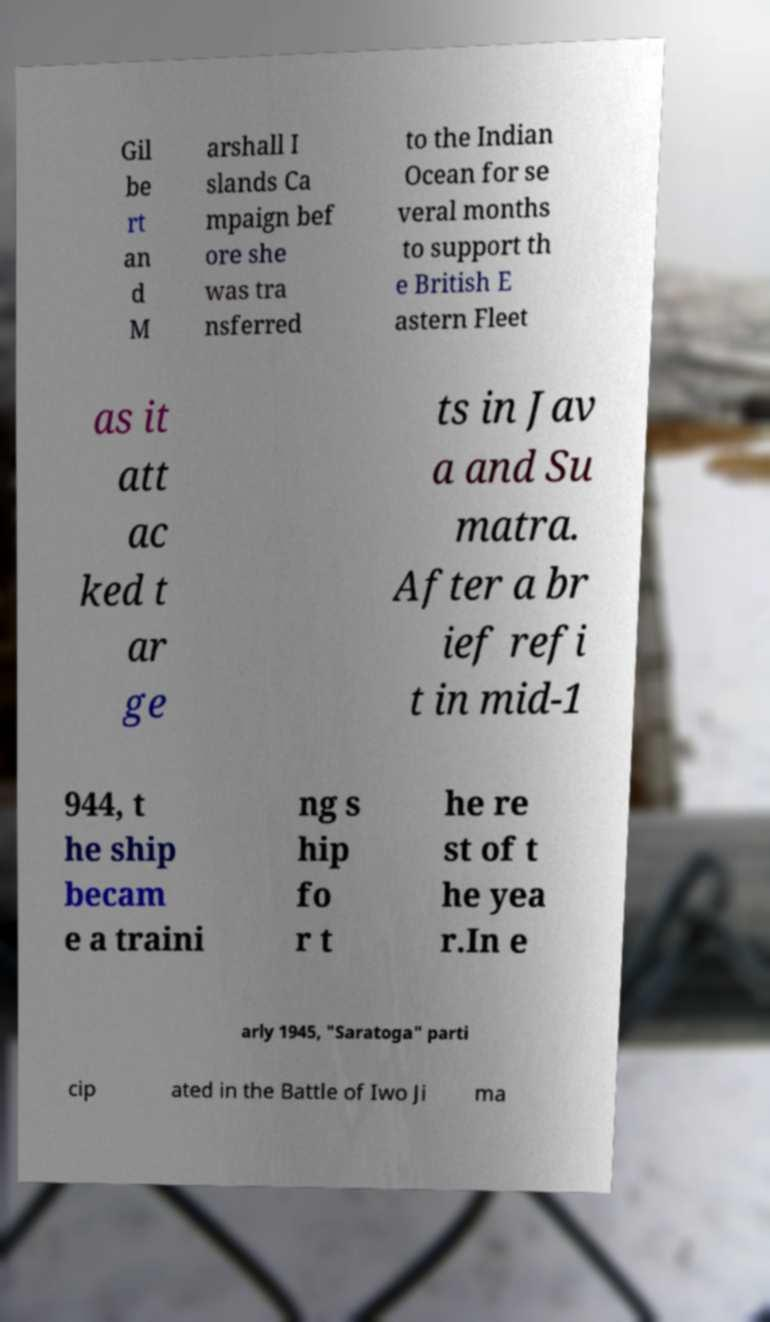Can you accurately transcribe the text from the provided image for me? Gil be rt an d M arshall I slands Ca mpaign bef ore she was tra nsferred to the Indian Ocean for se veral months to support th e British E astern Fleet as it att ac ked t ar ge ts in Jav a and Su matra. After a br ief refi t in mid-1 944, t he ship becam e a traini ng s hip fo r t he re st of t he yea r.In e arly 1945, "Saratoga" parti cip ated in the Battle of Iwo Ji ma 